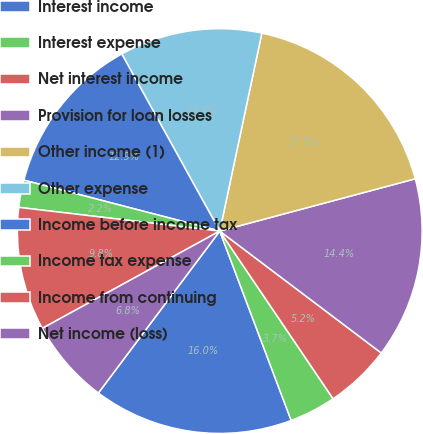<chart> <loc_0><loc_0><loc_500><loc_500><pie_chart><fcel>Interest income<fcel>Interest expense<fcel>Net interest income<fcel>Provision for loan losses<fcel>Other income (1)<fcel>Other expense<fcel>Income before income tax<fcel>Income tax expense<fcel>Income from continuing<fcel>Net income (loss)<nl><fcel>15.98%<fcel>3.72%<fcel>5.25%<fcel>14.45%<fcel>17.51%<fcel>11.38%<fcel>12.91%<fcel>2.18%<fcel>9.85%<fcel>6.78%<nl></chart> 